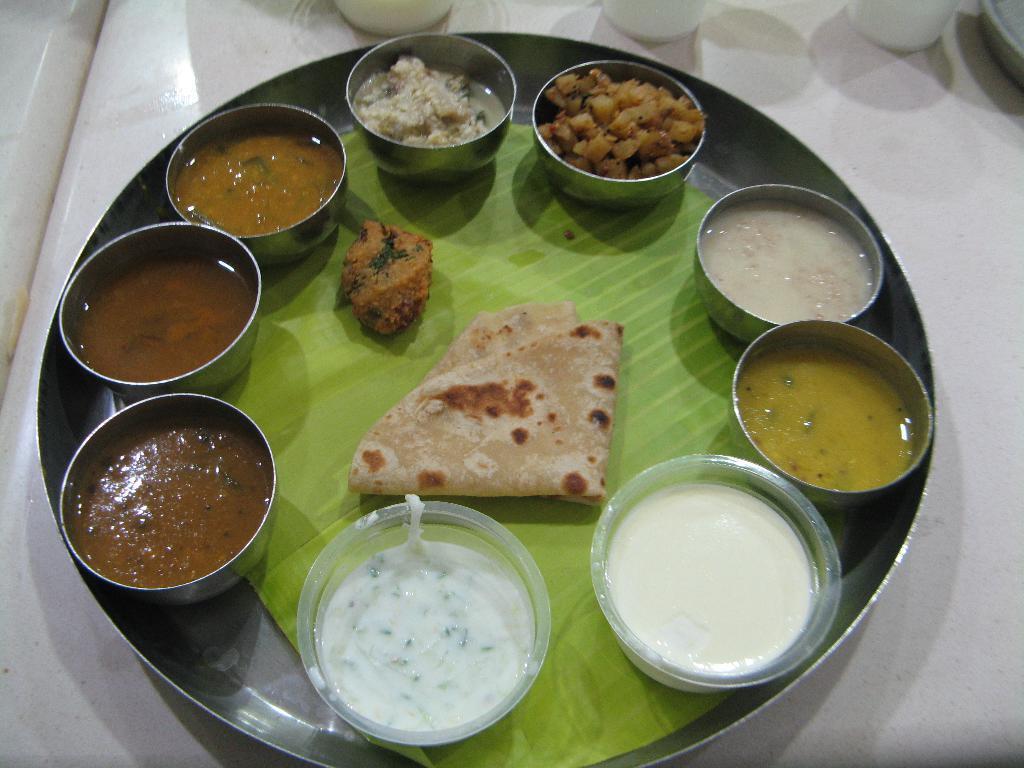Can you describe this image briefly? In the center of the image there is a plate on the table. In plate there are many food items. 